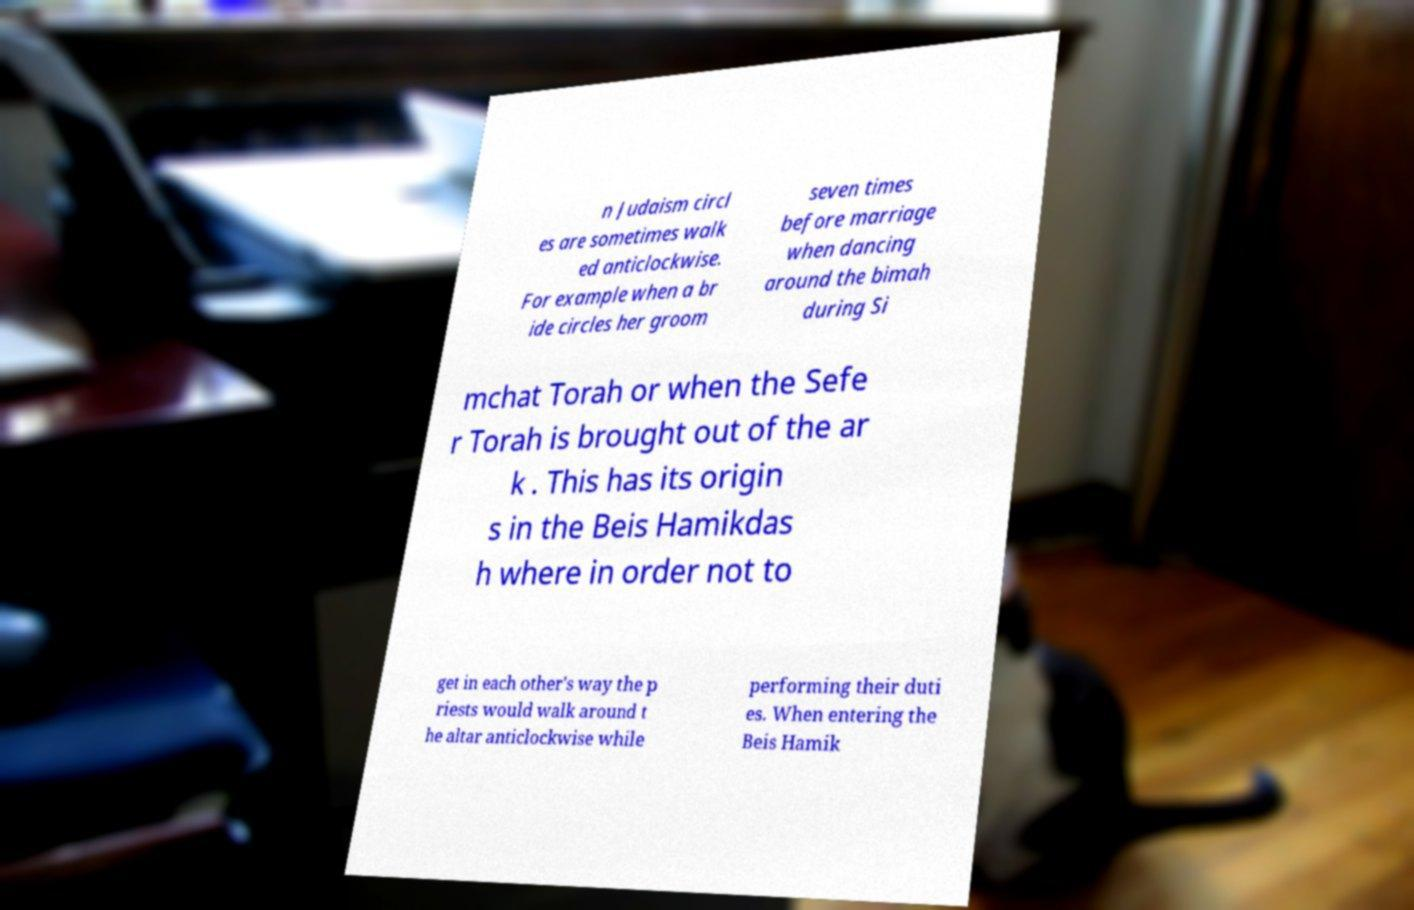There's text embedded in this image that I need extracted. Can you transcribe it verbatim? n Judaism circl es are sometimes walk ed anticlockwise. For example when a br ide circles her groom seven times before marriage when dancing around the bimah during Si mchat Torah or when the Sefe r Torah is brought out of the ar k . This has its origin s in the Beis Hamikdas h where in order not to get in each other's way the p riests would walk around t he altar anticlockwise while performing their duti es. When entering the Beis Hamik 